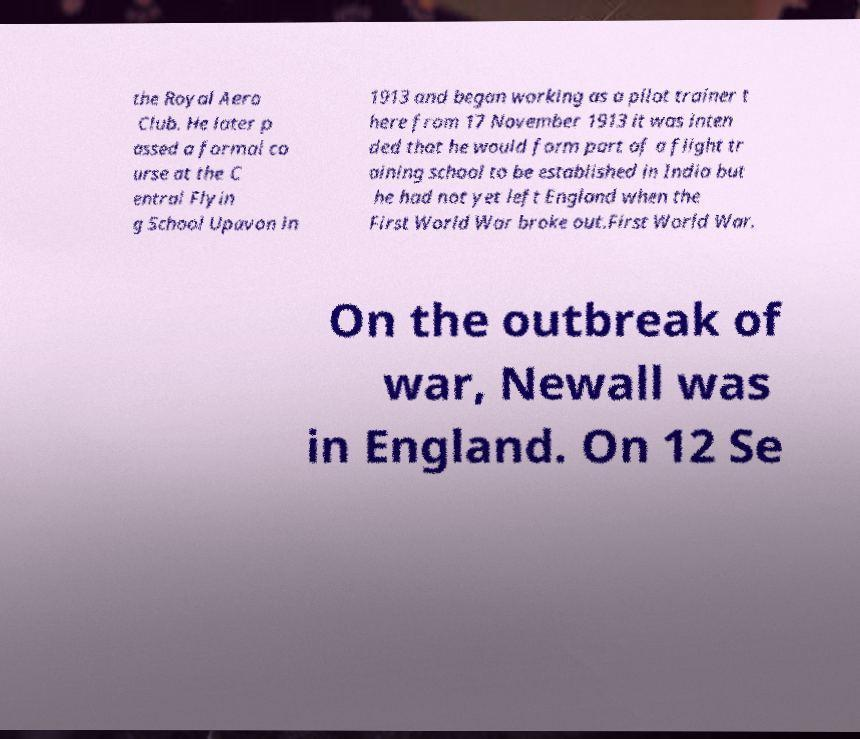For documentation purposes, I need the text within this image transcribed. Could you provide that? the Royal Aero Club. He later p assed a formal co urse at the C entral Flyin g School Upavon in 1913 and began working as a pilot trainer t here from 17 November 1913 it was inten ded that he would form part of a flight tr aining school to be established in India but he had not yet left England when the First World War broke out.First World War. On the outbreak of war, Newall was in England. On 12 Se 